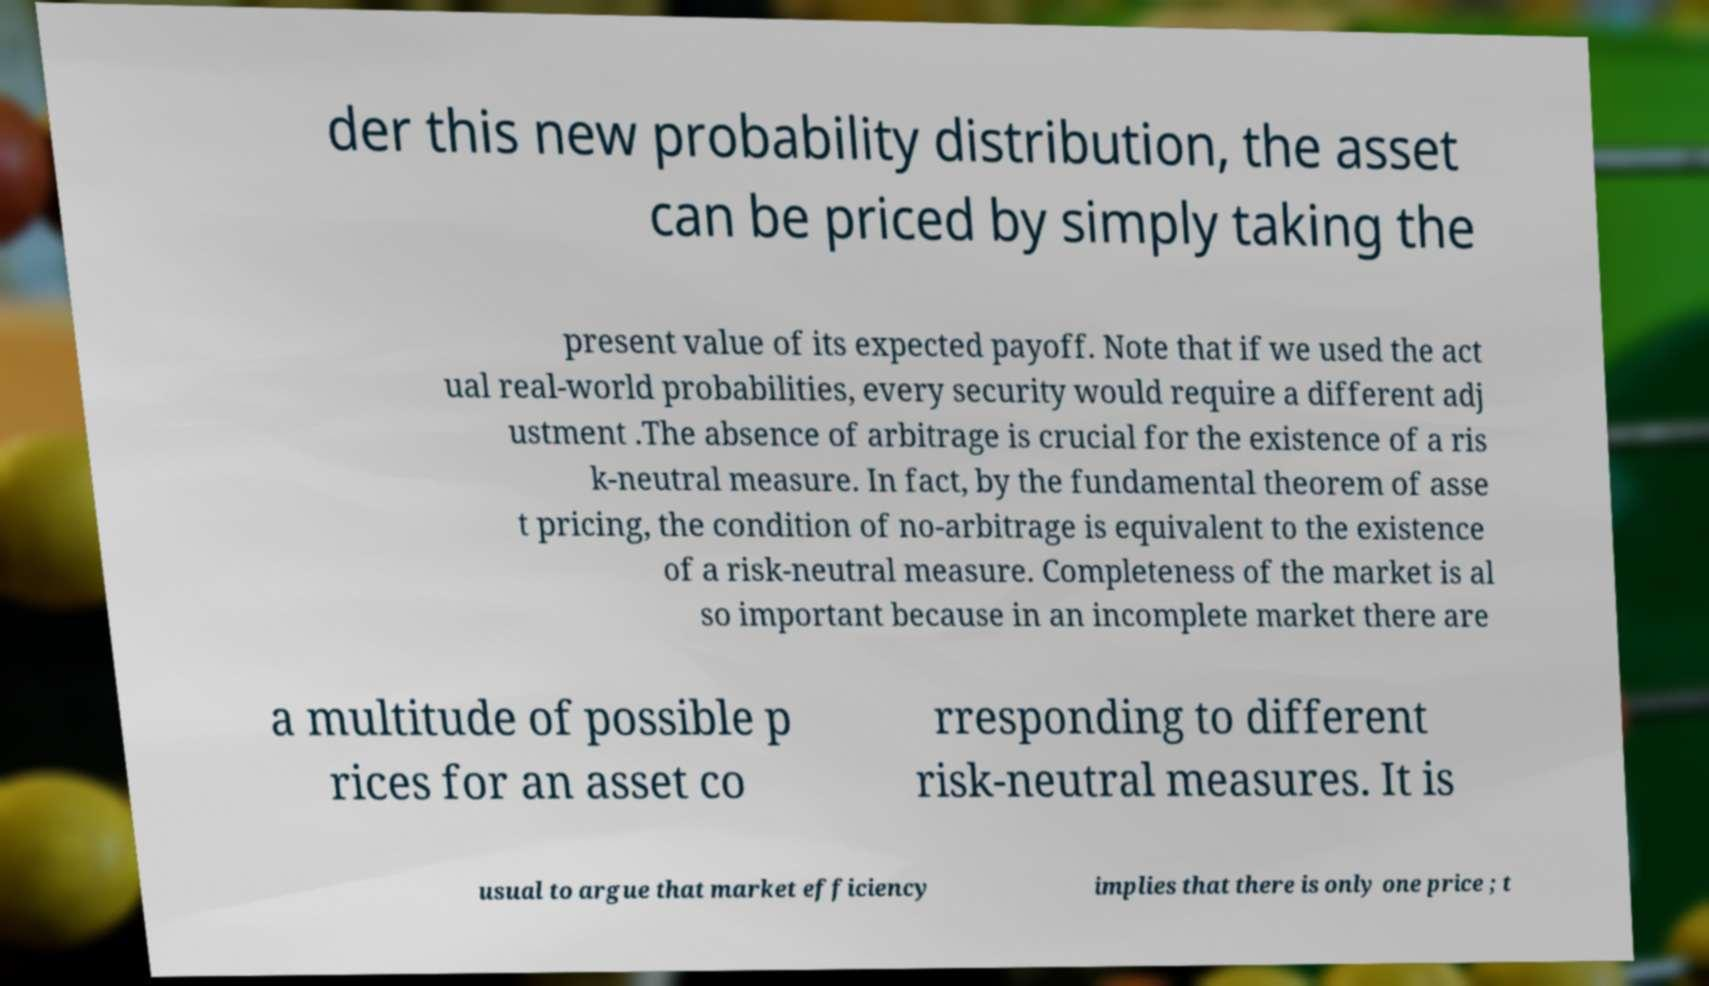Please identify and transcribe the text found in this image. der this new probability distribution, the asset can be priced by simply taking the present value of its expected payoff. Note that if we used the act ual real-world probabilities, every security would require a different adj ustment .The absence of arbitrage is crucial for the existence of a ris k-neutral measure. In fact, by the fundamental theorem of asse t pricing, the condition of no-arbitrage is equivalent to the existence of a risk-neutral measure. Completeness of the market is al so important because in an incomplete market there are a multitude of possible p rices for an asset co rresponding to different risk-neutral measures. It is usual to argue that market efficiency implies that there is only one price ; t 